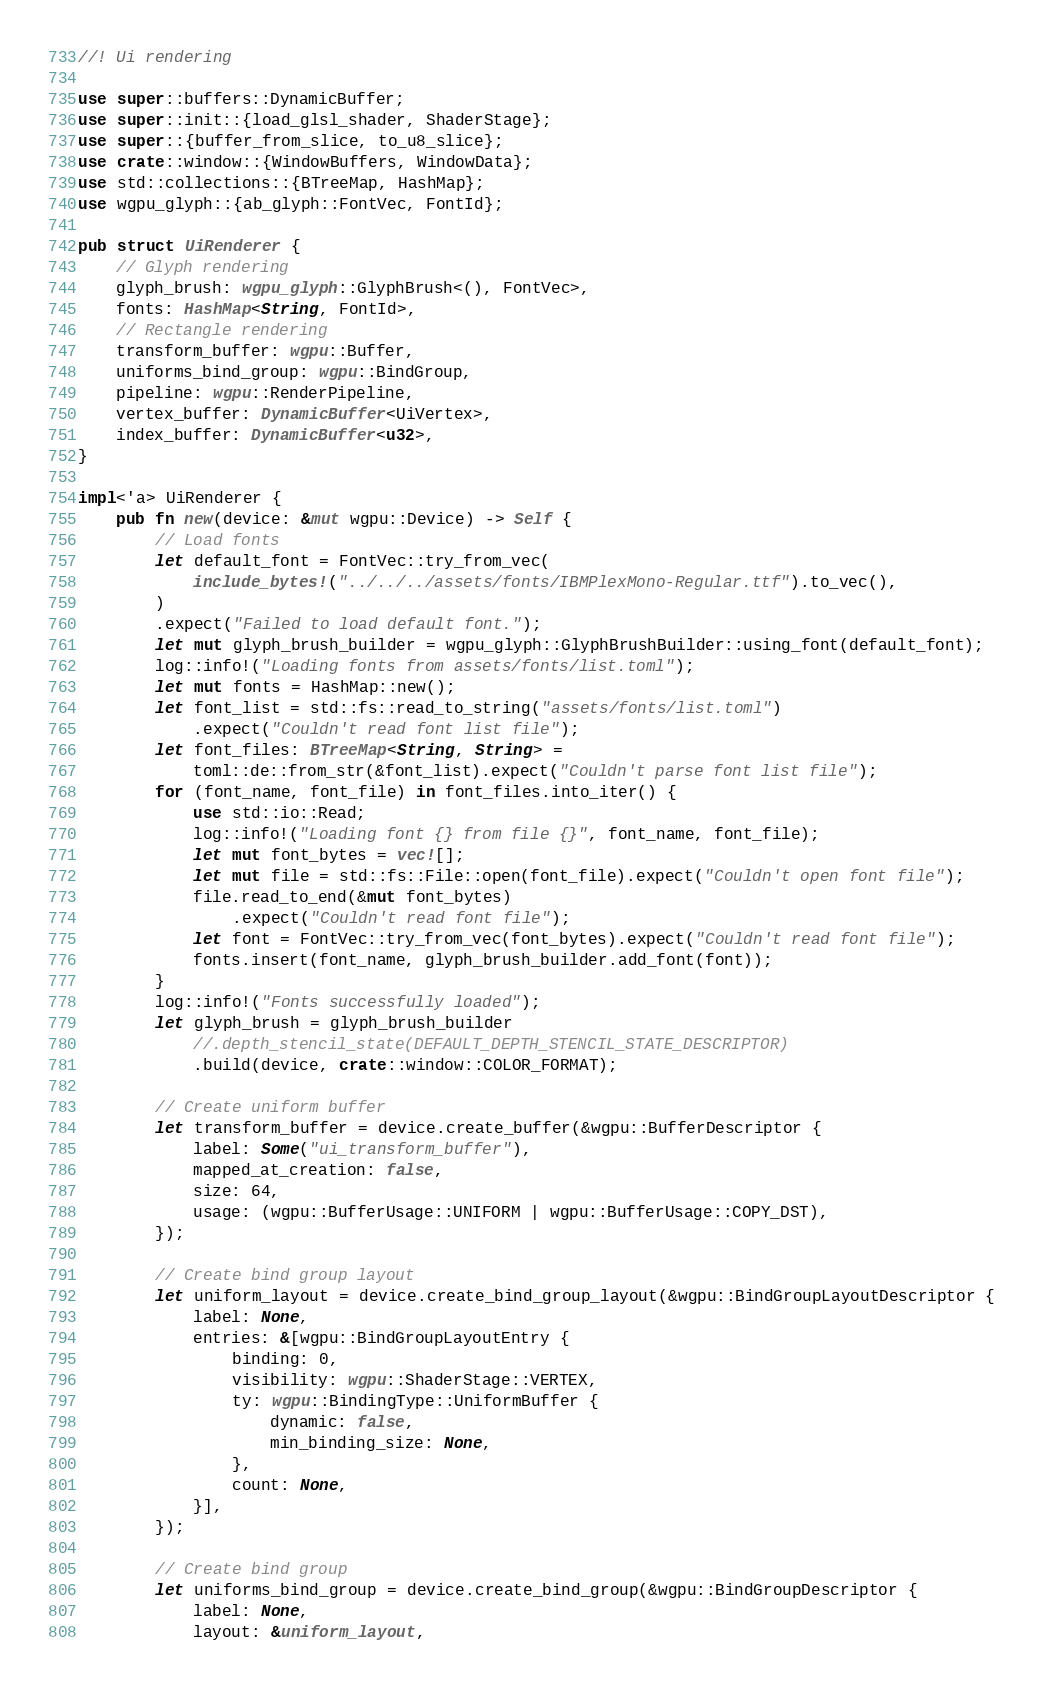Convert code to text. <code><loc_0><loc_0><loc_500><loc_500><_Rust_>//! Ui rendering

use super::buffers::DynamicBuffer;
use super::init::{load_glsl_shader, ShaderStage};
use super::{buffer_from_slice, to_u8_slice};
use crate::window::{WindowBuffers, WindowData};
use std::collections::{BTreeMap, HashMap};
use wgpu_glyph::{ab_glyph::FontVec, FontId};

pub struct UiRenderer {
    // Glyph rendering
    glyph_brush: wgpu_glyph::GlyphBrush<(), FontVec>,
    fonts: HashMap<String, FontId>,
    // Rectangle rendering
    transform_buffer: wgpu::Buffer,
    uniforms_bind_group: wgpu::BindGroup,
    pipeline: wgpu::RenderPipeline,
    vertex_buffer: DynamicBuffer<UiVertex>,
    index_buffer: DynamicBuffer<u32>,
}

impl<'a> UiRenderer {
    pub fn new(device: &mut wgpu::Device) -> Self {
        // Load fonts
        let default_font = FontVec::try_from_vec(
            include_bytes!("../../../assets/fonts/IBMPlexMono-Regular.ttf").to_vec(),
        )
        .expect("Failed to load default font.");
        let mut glyph_brush_builder = wgpu_glyph::GlyphBrushBuilder::using_font(default_font);
        log::info!("Loading fonts from assets/fonts/list.toml");
        let mut fonts = HashMap::new();
        let font_list = std::fs::read_to_string("assets/fonts/list.toml")
            .expect("Couldn't read font list file");
        let font_files: BTreeMap<String, String> =
            toml::de::from_str(&font_list).expect("Couldn't parse font list file");
        for (font_name, font_file) in font_files.into_iter() {
            use std::io::Read;
            log::info!("Loading font {} from file {}", font_name, font_file);
            let mut font_bytes = vec![];
            let mut file = std::fs::File::open(font_file).expect("Couldn't open font file");
            file.read_to_end(&mut font_bytes)
                .expect("Couldn't read font file");
            let font = FontVec::try_from_vec(font_bytes).expect("Couldn't read font file");
            fonts.insert(font_name, glyph_brush_builder.add_font(font));
        }
        log::info!("Fonts successfully loaded");
        let glyph_brush = glyph_brush_builder
            //.depth_stencil_state(DEFAULT_DEPTH_STENCIL_STATE_DESCRIPTOR)
            .build(device, crate::window::COLOR_FORMAT);

        // Create uniform buffer
        let transform_buffer = device.create_buffer(&wgpu::BufferDescriptor {
            label: Some("ui_transform_buffer"),
            mapped_at_creation: false,
            size: 64,
            usage: (wgpu::BufferUsage::UNIFORM | wgpu::BufferUsage::COPY_DST),
        });

        // Create bind group layout
        let uniform_layout = device.create_bind_group_layout(&wgpu::BindGroupLayoutDescriptor {
            label: None,
            entries: &[wgpu::BindGroupLayoutEntry {
                binding: 0,
                visibility: wgpu::ShaderStage::VERTEX,
                ty: wgpu::BindingType::UniformBuffer {
                    dynamic: false,
                    min_binding_size: None,
                },
                count: None,
            }],
        });

        // Create bind group
        let uniforms_bind_group = device.create_bind_group(&wgpu::BindGroupDescriptor {
            label: None,
            layout: &uniform_layout,</code> 